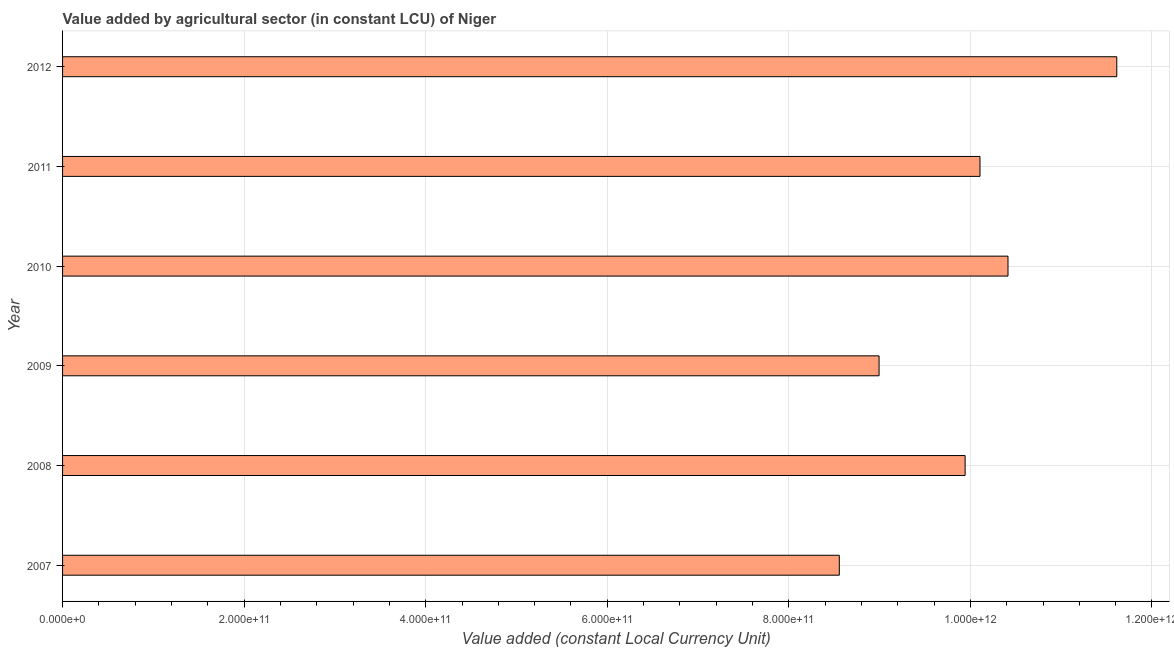Does the graph contain any zero values?
Offer a terse response. No. What is the title of the graph?
Provide a succinct answer. Value added by agricultural sector (in constant LCU) of Niger. What is the label or title of the X-axis?
Keep it short and to the point. Value added (constant Local Currency Unit). What is the value added by agriculture sector in 2007?
Your response must be concise. 8.56e+11. Across all years, what is the maximum value added by agriculture sector?
Ensure brevity in your answer.  1.16e+12. Across all years, what is the minimum value added by agriculture sector?
Ensure brevity in your answer.  8.56e+11. In which year was the value added by agriculture sector maximum?
Give a very brief answer. 2012. In which year was the value added by agriculture sector minimum?
Keep it short and to the point. 2007. What is the sum of the value added by agriculture sector?
Offer a very short reply. 5.96e+12. What is the difference between the value added by agriculture sector in 2008 and 2009?
Offer a terse response. 9.48e+1. What is the average value added by agriculture sector per year?
Your response must be concise. 9.94e+11. What is the median value added by agriculture sector?
Provide a succinct answer. 1.00e+12. What is the ratio of the value added by agriculture sector in 2010 to that in 2011?
Your response must be concise. 1.03. Is the difference between the value added by agriculture sector in 2008 and 2010 greater than the difference between any two years?
Offer a terse response. No. What is the difference between the highest and the second highest value added by agriculture sector?
Your response must be concise. 1.20e+11. What is the difference between the highest and the lowest value added by agriculture sector?
Provide a succinct answer. 3.06e+11. How many bars are there?
Your response must be concise. 6. What is the difference between two consecutive major ticks on the X-axis?
Provide a succinct answer. 2.00e+11. Are the values on the major ticks of X-axis written in scientific E-notation?
Provide a short and direct response. Yes. What is the Value added (constant Local Currency Unit) of 2007?
Your answer should be compact. 8.56e+11. What is the Value added (constant Local Currency Unit) in 2008?
Offer a terse response. 9.94e+11. What is the Value added (constant Local Currency Unit) of 2009?
Your answer should be compact. 8.99e+11. What is the Value added (constant Local Currency Unit) in 2010?
Give a very brief answer. 1.04e+12. What is the Value added (constant Local Currency Unit) of 2011?
Your response must be concise. 1.01e+12. What is the Value added (constant Local Currency Unit) of 2012?
Provide a short and direct response. 1.16e+12. What is the difference between the Value added (constant Local Currency Unit) in 2007 and 2008?
Provide a short and direct response. -1.39e+11. What is the difference between the Value added (constant Local Currency Unit) in 2007 and 2009?
Your answer should be compact. -4.38e+1. What is the difference between the Value added (constant Local Currency Unit) in 2007 and 2010?
Make the answer very short. -1.86e+11. What is the difference between the Value added (constant Local Currency Unit) in 2007 and 2011?
Provide a succinct answer. -1.55e+11. What is the difference between the Value added (constant Local Currency Unit) in 2007 and 2012?
Ensure brevity in your answer.  -3.06e+11. What is the difference between the Value added (constant Local Currency Unit) in 2008 and 2009?
Make the answer very short. 9.48e+1. What is the difference between the Value added (constant Local Currency Unit) in 2008 and 2010?
Keep it short and to the point. -4.72e+1. What is the difference between the Value added (constant Local Currency Unit) in 2008 and 2011?
Give a very brief answer. -1.64e+1. What is the difference between the Value added (constant Local Currency Unit) in 2008 and 2012?
Give a very brief answer. -1.67e+11. What is the difference between the Value added (constant Local Currency Unit) in 2009 and 2010?
Provide a succinct answer. -1.42e+11. What is the difference between the Value added (constant Local Currency Unit) in 2009 and 2011?
Offer a terse response. -1.11e+11. What is the difference between the Value added (constant Local Currency Unit) in 2009 and 2012?
Offer a very short reply. -2.62e+11. What is the difference between the Value added (constant Local Currency Unit) in 2010 and 2011?
Ensure brevity in your answer.  3.09e+1. What is the difference between the Value added (constant Local Currency Unit) in 2010 and 2012?
Offer a terse response. -1.20e+11. What is the difference between the Value added (constant Local Currency Unit) in 2011 and 2012?
Provide a succinct answer. -1.51e+11. What is the ratio of the Value added (constant Local Currency Unit) in 2007 to that in 2008?
Your response must be concise. 0.86. What is the ratio of the Value added (constant Local Currency Unit) in 2007 to that in 2009?
Your response must be concise. 0.95. What is the ratio of the Value added (constant Local Currency Unit) in 2007 to that in 2010?
Provide a short and direct response. 0.82. What is the ratio of the Value added (constant Local Currency Unit) in 2007 to that in 2011?
Provide a short and direct response. 0.85. What is the ratio of the Value added (constant Local Currency Unit) in 2007 to that in 2012?
Make the answer very short. 0.74. What is the ratio of the Value added (constant Local Currency Unit) in 2008 to that in 2009?
Your answer should be very brief. 1.1. What is the ratio of the Value added (constant Local Currency Unit) in 2008 to that in 2010?
Offer a very short reply. 0.95. What is the ratio of the Value added (constant Local Currency Unit) in 2008 to that in 2011?
Your answer should be very brief. 0.98. What is the ratio of the Value added (constant Local Currency Unit) in 2008 to that in 2012?
Your response must be concise. 0.86. What is the ratio of the Value added (constant Local Currency Unit) in 2009 to that in 2010?
Your answer should be very brief. 0.86. What is the ratio of the Value added (constant Local Currency Unit) in 2009 to that in 2011?
Your response must be concise. 0.89. What is the ratio of the Value added (constant Local Currency Unit) in 2009 to that in 2012?
Offer a terse response. 0.78. What is the ratio of the Value added (constant Local Currency Unit) in 2010 to that in 2011?
Ensure brevity in your answer.  1.03. What is the ratio of the Value added (constant Local Currency Unit) in 2010 to that in 2012?
Your answer should be compact. 0.9. What is the ratio of the Value added (constant Local Currency Unit) in 2011 to that in 2012?
Your answer should be very brief. 0.87. 